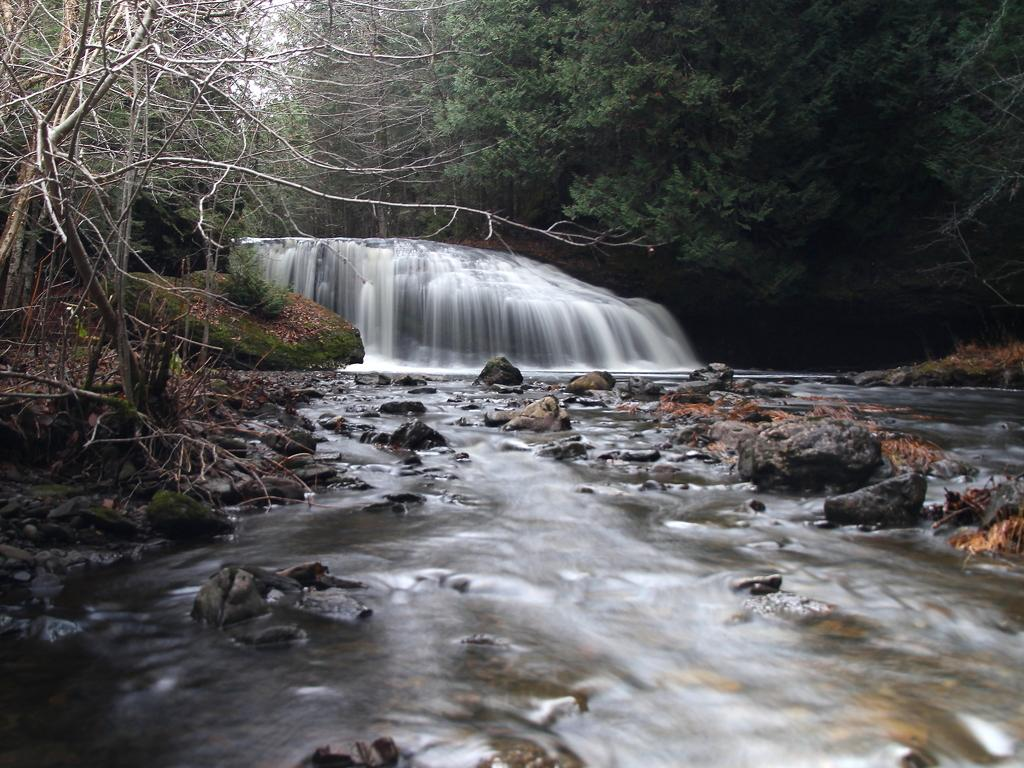What is the main feature in the middle of the image? There is a waterfall in the middle of the image. What can be seen at the base of the waterfall? There are stones at the bottom of the waterfall. What is the condition of the stones at the base of the waterfall? Water is present on the stones. What type of vegetation is on the right side of the waterfall? There are trees on the right side of the waterfall. What type of operation is being performed on the waterfall in the image? There is no operation being performed on the waterfall in the image; it is a natural scene. What scientific principles can be observed in the image? The image does not specifically illustrate any scientific principles; it is a picture of a waterfall and its surroundings. 